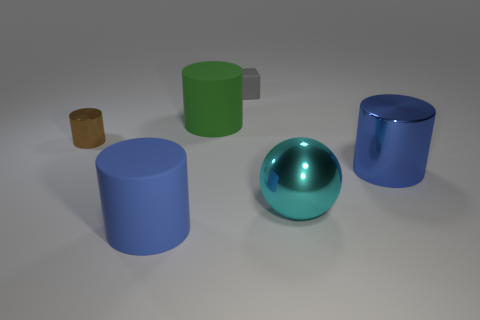Is there anything else that has the same shape as the small gray thing?
Ensure brevity in your answer.  No. How many other things are there of the same color as the big shiny cylinder?
Your answer should be compact. 1. What number of metal things are gray things or large red cylinders?
Offer a terse response. 0. There is a metal cylinder that is to the left of the green cylinder; is its color the same as the cylinder on the right side of the small gray cube?
Give a very brief answer. No. Is there anything else that has the same material as the small brown cylinder?
Offer a very short reply. Yes. The green rubber object that is the same shape as the blue shiny thing is what size?
Keep it short and to the point. Large. Are there more small cylinders right of the brown cylinder than tiny brown things?
Keep it short and to the point. No. Is the small object that is behind the large green cylinder made of the same material as the large cyan ball?
Keep it short and to the point. No. There is a blue cylinder that is right of the matte block on the right side of the big rubber cylinder that is behind the small metallic object; what is its size?
Offer a terse response. Large. There is a blue cylinder that is the same material as the gray cube; what is its size?
Your answer should be compact. Large. 